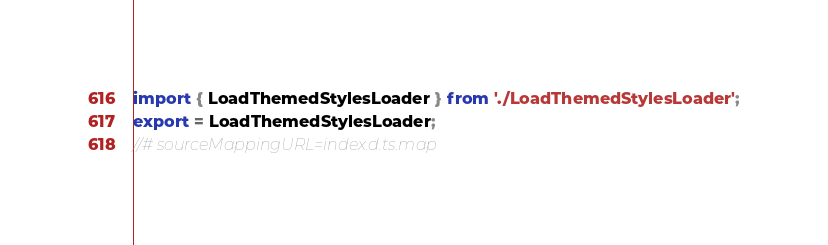Convert code to text. <code><loc_0><loc_0><loc_500><loc_500><_TypeScript_>import { LoadThemedStylesLoader } from './LoadThemedStylesLoader';
export = LoadThemedStylesLoader;
//# sourceMappingURL=index.d.ts.map</code> 